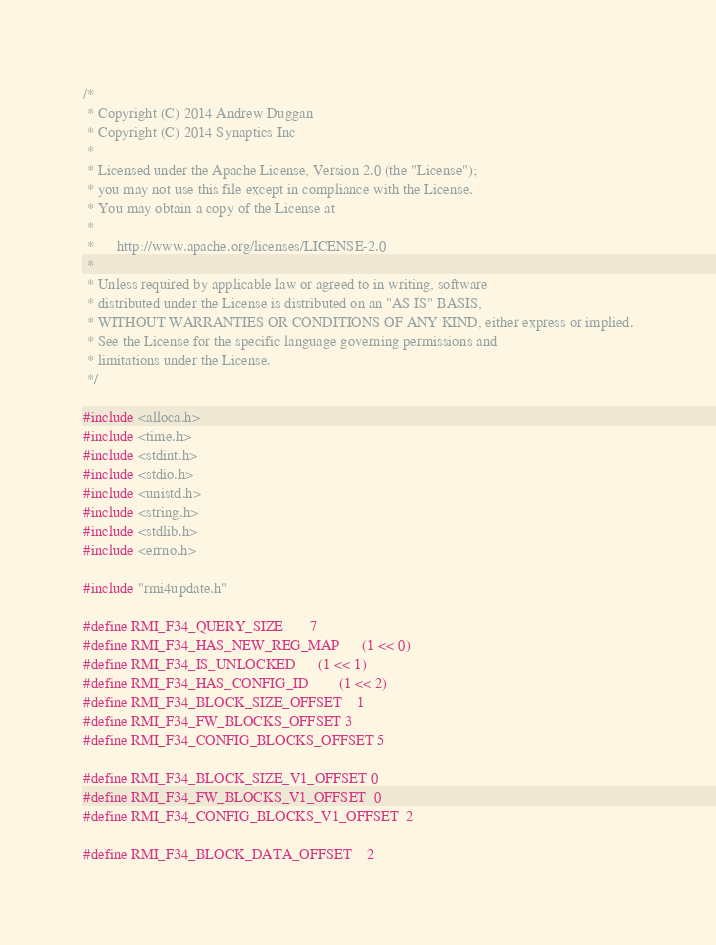<code> <loc_0><loc_0><loc_500><loc_500><_C++_>/*
 * Copyright (C) 2014 Andrew Duggan
 * Copyright (C) 2014 Synaptics Inc
 *
 * Licensed under the Apache License, Version 2.0 (the "License");
 * you may not use this file except in compliance with the License.
 * You may obtain a copy of the License at
 *
 *      http://www.apache.org/licenses/LICENSE-2.0
 *
 * Unless required by applicable law or agreed to in writing, software
 * distributed under the License is distributed on an "AS IS" BASIS,
 * WITHOUT WARRANTIES OR CONDITIONS OF ANY KIND, either express or implied.
 * See the License for the specific language governing permissions and
 * limitations under the License.
 */

#include <alloca.h>
#include <time.h>
#include <stdint.h>
#include <stdio.h>
#include <unistd.h>
#include <string.h>
#include <stdlib.h>
#include <errno.h>

#include "rmi4update.h"

#define RMI_F34_QUERY_SIZE		7
#define RMI_F34_HAS_NEW_REG_MAP		(1 << 0)
#define RMI_F34_IS_UNLOCKED		(1 << 1)
#define RMI_F34_HAS_CONFIG_ID		(1 << 2)
#define RMI_F34_BLOCK_SIZE_OFFSET	1
#define RMI_F34_FW_BLOCKS_OFFSET	3
#define RMI_F34_CONFIG_BLOCKS_OFFSET	5

#define RMI_F34_BLOCK_SIZE_V1_OFFSET	0
#define RMI_F34_FW_BLOCKS_V1_OFFSET	0
#define RMI_F34_CONFIG_BLOCKS_V1_OFFSET	2

#define RMI_F34_BLOCK_DATA_OFFSET	2</code> 